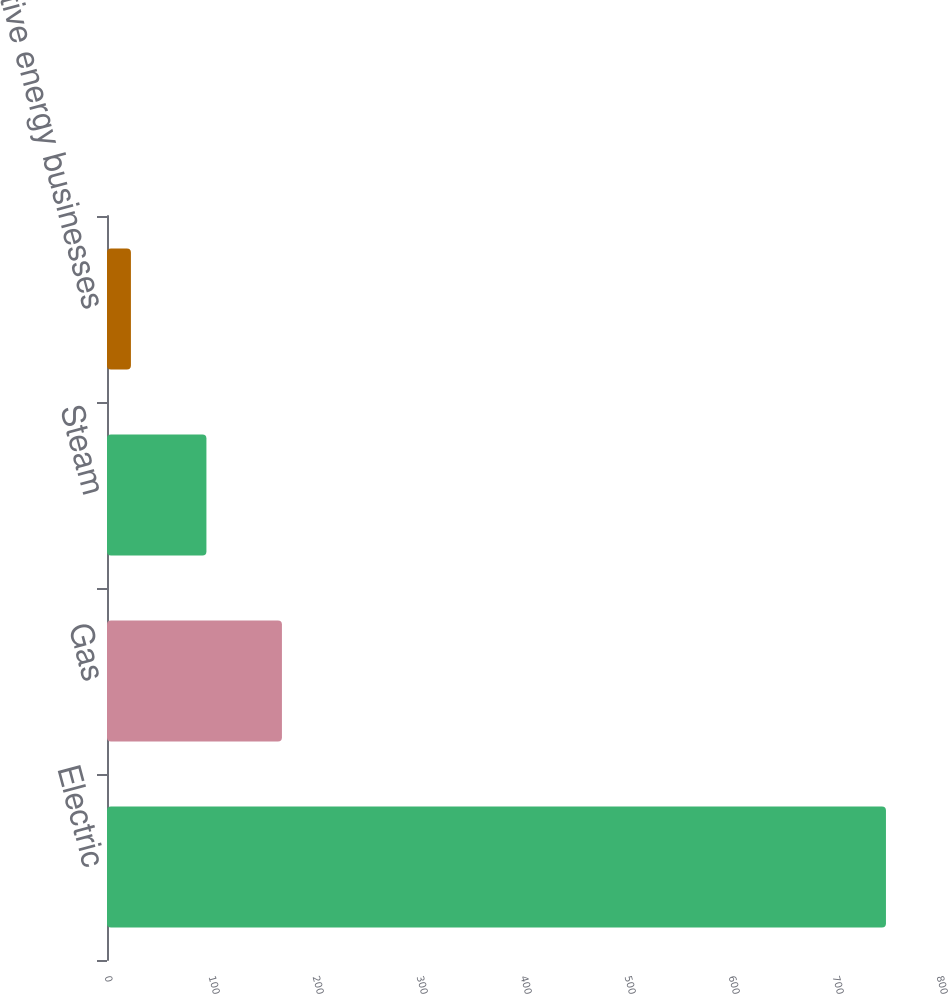Convert chart to OTSL. <chart><loc_0><loc_0><loc_500><loc_500><bar_chart><fcel>Electric<fcel>Gas<fcel>Steam<fcel>Competitive energy businesses<nl><fcel>749<fcel>168.2<fcel>95.6<fcel>23<nl></chart> 